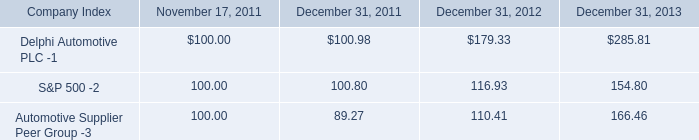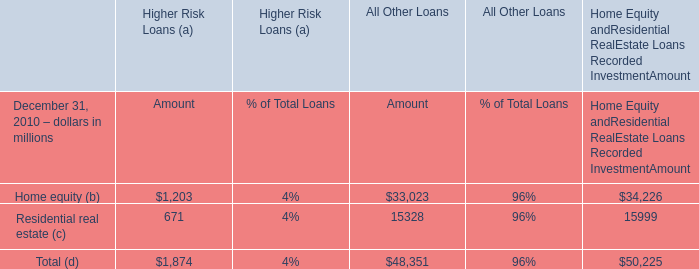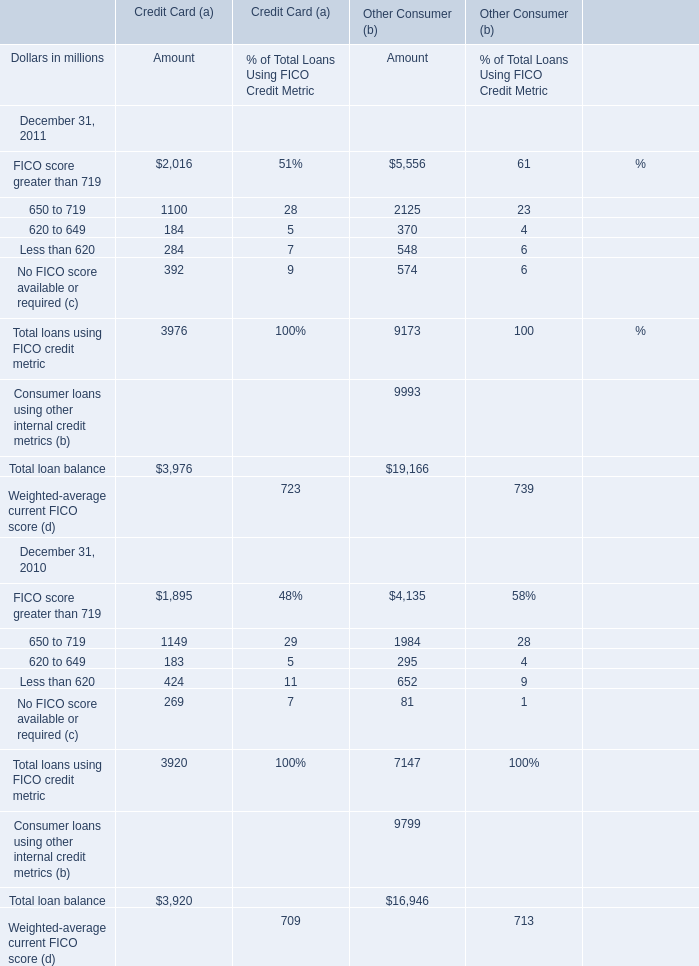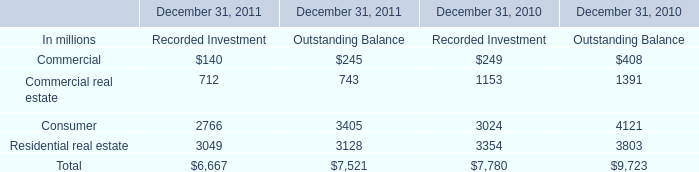In the year with largest amount of FICO score greater than 719, what's the sum of 650 to 719? (in million) 
Computations: (1100 + 2125)
Answer: 3225.0. 